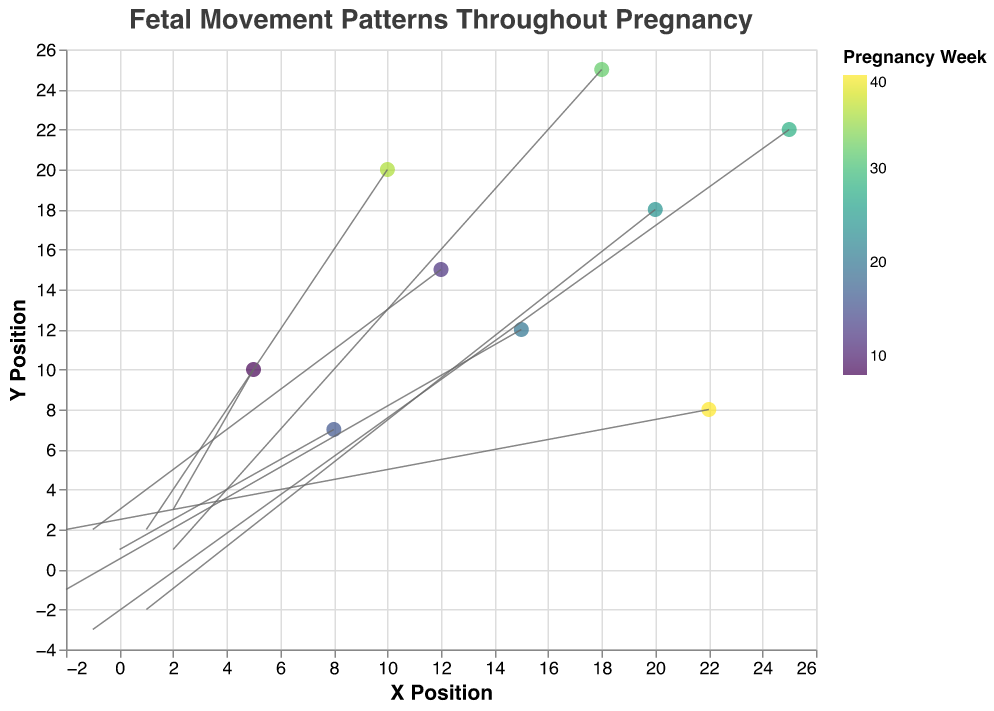what is the title of the plot? The title is displayed at the top of the plot and describes what the plot is about. Here, the title provided in the code indicates "Fetal Movement Patterns Throughout Pregnancy."
Answer: Fetal Movement Patterns Throughout Pregnancy Which axis represents the X position? The axis representing the X position is labeled "X Position" as indicated in the X encoding configuration.
Answer: The horizontal axis At which week is the X movement direction positive? To determine this, we look at the values of the "u" component in the data points, which represent the X direction. Positive X direction (u > 0) is observed in weeks 8, 24, 32, and 36.
Answer: Week 8, 24, 32, and 36 How many data points are plotted in the graph? Each row in the data represents a data point. Counting the rows, we see there are nine data points.
Answer: 9 What colors are used to represent different pregnancy weeks? The color encoding uses a "viridis" color scheme that varies with each pregnancy week. The legend provides a gradient of colors mapped to different weeks.
Answer: A range from blue to yellow-green What's the total movement in Y direction for the data points at week 20 and week 32? To find the total, we sum the "v" values for weeks 20 and 32. The "v" values are -1 (week 20) and 1 (week 32). Thus the sum is -1 + 1 = 0.
Answer: 0 Which data point has the highest Y position? We refer to the "y" values in the dataset and identify the maximum value. The highest Y value is 25 at week 32.
Answer: Week 32 In which week does the data point at (15, 12) occur? Observing the data, the point (15, 12) corresponds with a week value of 20.
Answer: Week 20 In which direction (positive or negative) does the fetus move more frequently in the later stages of pregnancy (weeks 24-40)? By analyzing the "u" and "v" values for weeks 24, 28, 32, 36, and 40, we note that: u (X direction) is mixed, while v (Y direction) is more frequently negative (weeks 24, 28) and positive (weeks 32, 36, 40).
Answer: Mixed (positive and negative) directions in X, Y direction is more varied Which week shows no movement in X direction? To find this, we look at the "u" values. The week with "u" equal to 0 is week 16 (data point: (8, 7) with u=0, v=1).
Answer: Week 16 